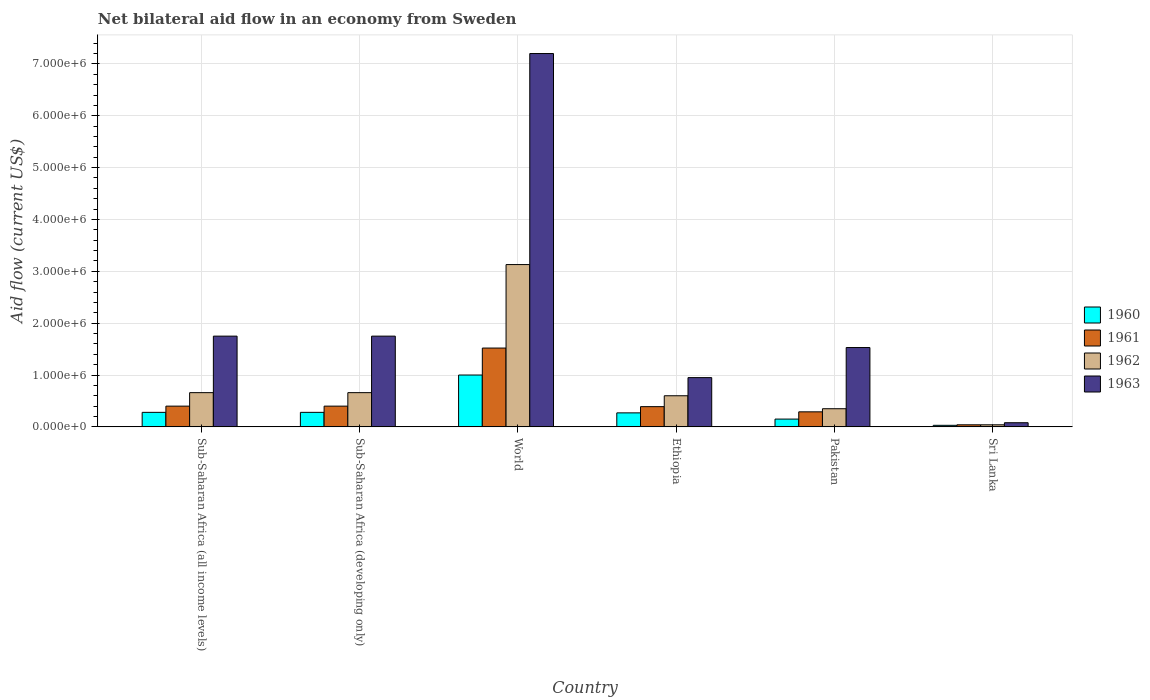How many different coloured bars are there?
Provide a short and direct response. 4. How many groups of bars are there?
Provide a short and direct response. 6. Are the number of bars on each tick of the X-axis equal?
Offer a terse response. Yes. How many bars are there on the 4th tick from the left?
Offer a terse response. 4. What is the label of the 6th group of bars from the left?
Provide a short and direct response. Sri Lanka. In how many cases, is the number of bars for a given country not equal to the number of legend labels?
Offer a very short reply. 0. Across all countries, what is the maximum net bilateral aid flow in 1963?
Offer a very short reply. 7.20e+06. Across all countries, what is the minimum net bilateral aid flow in 1962?
Give a very brief answer. 4.00e+04. In which country was the net bilateral aid flow in 1963 minimum?
Offer a very short reply. Sri Lanka. What is the total net bilateral aid flow in 1963 in the graph?
Make the answer very short. 1.33e+07. What is the average net bilateral aid flow in 1960 per country?
Provide a short and direct response. 3.35e+05. What is the difference between the net bilateral aid flow of/in 1960 and net bilateral aid flow of/in 1961 in World?
Make the answer very short. -5.20e+05. In how many countries, is the net bilateral aid flow in 1960 greater than 4600000 US$?
Offer a terse response. 0. What is the difference between the highest and the second highest net bilateral aid flow in 1960?
Keep it short and to the point. 7.20e+05. What is the difference between the highest and the lowest net bilateral aid flow in 1963?
Offer a very short reply. 7.12e+06. In how many countries, is the net bilateral aid flow in 1962 greater than the average net bilateral aid flow in 1962 taken over all countries?
Give a very brief answer. 1. Is the sum of the net bilateral aid flow in 1962 in Sub-Saharan Africa (developing only) and World greater than the maximum net bilateral aid flow in 1960 across all countries?
Your answer should be compact. Yes. How many countries are there in the graph?
Provide a short and direct response. 6. How are the legend labels stacked?
Provide a short and direct response. Vertical. What is the title of the graph?
Give a very brief answer. Net bilateral aid flow in an economy from Sweden. Does "1990" appear as one of the legend labels in the graph?
Your answer should be very brief. No. What is the label or title of the X-axis?
Offer a terse response. Country. What is the label or title of the Y-axis?
Offer a very short reply. Aid flow (current US$). What is the Aid flow (current US$) of 1962 in Sub-Saharan Africa (all income levels)?
Give a very brief answer. 6.60e+05. What is the Aid flow (current US$) in 1963 in Sub-Saharan Africa (all income levels)?
Keep it short and to the point. 1.75e+06. What is the Aid flow (current US$) in 1962 in Sub-Saharan Africa (developing only)?
Your answer should be compact. 6.60e+05. What is the Aid flow (current US$) in 1963 in Sub-Saharan Africa (developing only)?
Offer a terse response. 1.75e+06. What is the Aid flow (current US$) of 1960 in World?
Make the answer very short. 1.00e+06. What is the Aid flow (current US$) of 1961 in World?
Offer a very short reply. 1.52e+06. What is the Aid flow (current US$) of 1962 in World?
Your answer should be compact. 3.13e+06. What is the Aid flow (current US$) of 1963 in World?
Provide a short and direct response. 7.20e+06. What is the Aid flow (current US$) in 1961 in Ethiopia?
Offer a terse response. 3.90e+05. What is the Aid flow (current US$) in 1963 in Ethiopia?
Give a very brief answer. 9.50e+05. What is the Aid flow (current US$) in 1960 in Pakistan?
Ensure brevity in your answer.  1.50e+05. What is the Aid flow (current US$) of 1963 in Pakistan?
Your answer should be compact. 1.53e+06. What is the Aid flow (current US$) of 1963 in Sri Lanka?
Your answer should be compact. 8.00e+04. Across all countries, what is the maximum Aid flow (current US$) of 1961?
Make the answer very short. 1.52e+06. Across all countries, what is the maximum Aid flow (current US$) of 1962?
Make the answer very short. 3.13e+06. Across all countries, what is the maximum Aid flow (current US$) in 1963?
Offer a terse response. 7.20e+06. Across all countries, what is the minimum Aid flow (current US$) of 1961?
Keep it short and to the point. 4.00e+04. What is the total Aid flow (current US$) of 1960 in the graph?
Provide a succinct answer. 2.01e+06. What is the total Aid flow (current US$) of 1961 in the graph?
Ensure brevity in your answer.  3.04e+06. What is the total Aid flow (current US$) of 1962 in the graph?
Your response must be concise. 5.44e+06. What is the total Aid flow (current US$) of 1963 in the graph?
Your answer should be very brief. 1.33e+07. What is the difference between the Aid flow (current US$) in 1961 in Sub-Saharan Africa (all income levels) and that in Sub-Saharan Africa (developing only)?
Keep it short and to the point. 0. What is the difference between the Aid flow (current US$) of 1962 in Sub-Saharan Africa (all income levels) and that in Sub-Saharan Africa (developing only)?
Offer a terse response. 0. What is the difference between the Aid flow (current US$) in 1960 in Sub-Saharan Africa (all income levels) and that in World?
Make the answer very short. -7.20e+05. What is the difference between the Aid flow (current US$) in 1961 in Sub-Saharan Africa (all income levels) and that in World?
Make the answer very short. -1.12e+06. What is the difference between the Aid flow (current US$) in 1962 in Sub-Saharan Africa (all income levels) and that in World?
Your response must be concise. -2.47e+06. What is the difference between the Aid flow (current US$) of 1963 in Sub-Saharan Africa (all income levels) and that in World?
Your response must be concise. -5.45e+06. What is the difference between the Aid flow (current US$) in 1960 in Sub-Saharan Africa (all income levels) and that in Ethiopia?
Your answer should be compact. 10000. What is the difference between the Aid flow (current US$) of 1963 in Sub-Saharan Africa (all income levels) and that in Pakistan?
Your answer should be very brief. 2.20e+05. What is the difference between the Aid flow (current US$) of 1961 in Sub-Saharan Africa (all income levels) and that in Sri Lanka?
Your response must be concise. 3.60e+05. What is the difference between the Aid flow (current US$) of 1962 in Sub-Saharan Africa (all income levels) and that in Sri Lanka?
Ensure brevity in your answer.  6.20e+05. What is the difference between the Aid flow (current US$) of 1963 in Sub-Saharan Africa (all income levels) and that in Sri Lanka?
Provide a short and direct response. 1.67e+06. What is the difference between the Aid flow (current US$) in 1960 in Sub-Saharan Africa (developing only) and that in World?
Offer a terse response. -7.20e+05. What is the difference between the Aid flow (current US$) in 1961 in Sub-Saharan Africa (developing only) and that in World?
Ensure brevity in your answer.  -1.12e+06. What is the difference between the Aid flow (current US$) of 1962 in Sub-Saharan Africa (developing only) and that in World?
Offer a terse response. -2.47e+06. What is the difference between the Aid flow (current US$) of 1963 in Sub-Saharan Africa (developing only) and that in World?
Your answer should be very brief. -5.45e+06. What is the difference between the Aid flow (current US$) of 1960 in Sub-Saharan Africa (developing only) and that in Ethiopia?
Make the answer very short. 10000. What is the difference between the Aid flow (current US$) of 1962 in Sub-Saharan Africa (developing only) and that in Ethiopia?
Ensure brevity in your answer.  6.00e+04. What is the difference between the Aid flow (current US$) in 1963 in Sub-Saharan Africa (developing only) and that in Ethiopia?
Provide a succinct answer. 8.00e+05. What is the difference between the Aid flow (current US$) of 1962 in Sub-Saharan Africa (developing only) and that in Pakistan?
Your response must be concise. 3.10e+05. What is the difference between the Aid flow (current US$) in 1963 in Sub-Saharan Africa (developing only) and that in Pakistan?
Provide a short and direct response. 2.20e+05. What is the difference between the Aid flow (current US$) of 1960 in Sub-Saharan Africa (developing only) and that in Sri Lanka?
Make the answer very short. 2.50e+05. What is the difference between the Aid flow (current US$) of 1962 in Sub-Saharan Africa (developing only) and that in Sri Lanka?
Your answer should be very brief. 6.20e+05. What is the difference between the Aid flow (current US$) of 1963 in Sub-Saharan Africa (developing only) and that in Sri Lanka?
Provide a short and direct response. 1.67e+06. What is the difference between the Aid flow (current US$) of 1960 in World and that in Ethiopia?
Ensure brevity in your answer.  7.30e+05. What is the difference between the Aid flow (current US$) in 1961 in World and that in Ethiopia?
Give a very brief answer. 1.13e+06. What is the difference between the Aid flow (current US$) of 1962 in World and that in Ethiopia?
Make the answer very short. 2.53e+06. What is the difference between the Aid flow (current US$) of 1963 in World and that in Ethiopia?
Offer a terse response. 6.25e+06. What is the difference between the Aid flow (current US$) of 1960 in World and that in Pakistan?
Your answer should be very brief. 8.50e+05. What is the difference between the Aid flow (current US$) in 1961 in World and that in Pakistan?
Your answer should be compact. 1.23e+06. What is the difference between the Aid flow (current US$) in 1962 in World and that in Pakistan?
Your answer should be compact. 2.78e+06. What is the difference between the Aid flow (current US$) in 1963 in World and that in Pakistan?
Offer a very short reply. 5.67e+06. What is the difference between the Aid flow (current US$) in 1960 in World and that in Sri Lanka?
Ensure brevity in your answer.  9.70e+05. What is the difference between the Aid flow (current US$) of 1961 in World and that in Sri Lanka?
Ensure brevity in your answer.  1.48e+06. What is the difference between the Aid flow (current US$) of 1962 in World and that in Sri Lanka?
Your answer should be compact. 3.09e+06. What is the difference between the Aid flow (current US$) of 1963 in World and that in Sri Lanka?
Provide a succinct answer. 7.12e+06. What is the difference between the Aid flow (current US$) of 1962 in Ethiopia and that in Pakistan?
Make the answer very short. 2.50e+05. What is the difference between the Aid flow (current US$) in 1963 in Ethiopia and that in Pakistan?
Ensure brevity in your answer.  -5.80e+05. What is the difference between the Aid flow (current US$) in 1960 in Ethiopia and that in Sri Lanka?
Offer a very short reply. 2.40e+05. What is the difference between the Aid flow (current US$) in 1962 in Ethiopia and that in Sri Lanka?
Give a very brief answer. 5.60e+05. What is the difference between the Aid flow (current US$) of 1963 in Ethiopia and that in Sri Lanka?
Your answer should be compact. 8.70e+05. What is the difference between the Aid flow (current US$) in 1960 in Pakistan and that in Sri Lanka?
Provide a short and direct response. 1.20e+05. What is the difference between the Aid flow (current US$) in 1961 in Pakistan and that in Sri Lanka?
Give a very brief answer. 2.50e+05. What is the difference between the Aid flow (current US$) in 1962 in Pakistan and that in Sri Lanka?
Provide a short and direct response. 3.10e+05. What is the difference between the Aid flow (current US$) of 1963 in Pakistan and that in Sri Lanka?
Ensure brevity in your answer.  1.45e+06. What is the difference between the Aid flow (current US$) of 1960 in Sub-Saharan Africa (all income levels) and the Aid flow (current US$) of 1961 in Sub-Saharan Africa (developing only)?
Keep it short and to the point. -1.20e+05. What is the difference between the Aid flow (current US$) of 1960 in Sub-Saharan Africa (all income levels) and the Aid flow (current US$) of 1962 in Sub-Saharan Africa (developing only)?
Provide a succinct answer. -3.80e+05. What is the difference between the Aid flow (current US$) in 1960 in Sub-Saharan Africa (all income levels) and the Aid flow (current US$) in 1963 in Sub-Saharan Africa (developing only)?
Provide a succinct answer. -1.47e+06. What is the difference between the Aid flow (current US$) of 1961 in Sub-Saharan Africa (all income levels) and the Aid flow (current US$) of 1963 in Sub-Saharan Africa (developing only)?
Your answer should be compact. -1.35e+06. What is the difference between the Aid flow (current US$) in 1962 in Sub-Saharan Africa (all income levels) and the Aid flow (current US$) in 1963 in Sub-Saharan Africa (developing only)?
Make the answer very short. -1.09e+06. What is the difference between the Aid flow (current US$) in 1960 in Sub-Saharan Africa (all income levels) and the Aid flow (current US$) in 1961 in World?
Your answer should be very brief. -1.24e+06. What is the difference between the Aid flow (current US$) of 1960 in Sub-Saharan Africa (all income levels) and the Aid flow (current US$) of 1962 in World?
Offer a terse response. -2.85e+06. What is the difference between the Aid flow (current US$) of 1960 in Sub-Saharan Africa (all income levels) and the Aid flow (current US$) of 1963 in World?
Provide a succinct answer. -6.92e+06. What is the difference between the Aid flow (current US$) in 1961 in Sub-Saharan Africa (all income levels) and the Aid flow (current US$) in 1962 in World?
Keep it short and to the point. -2.73e+06. What is the difference between the Aid flow (current US$) in 1961 in Sub-Saharan Africa (all income levels) and the Aid flow (current US$) in 1963 in World?
Provide a succinct answer. -6.80e+06. What is the difference between the Aid flow (current US$) in 1962 in Sub-Saharan Africa (all income levels) and the Aid flow (current US$) in 1963 in World?
Offer a terse response. -6.54e+06. What is the difference between the Aid flow (current US$) of 1960 in Sub-Saharan Africa (all income levels) and the Aid flow (current US$) of 1961 in Ethiopia?
Ensure brevity in your answer.  -1.10e+05. What is the difference between the Aid flow (current US$) in 1960 in Sub-Saharan Africa (all income levels) and the Aid flow (current US$) in 1962 in Ethiopia?
Give a very brief answer. -3.20e+05. What is the difference between the Aid flow (current US$) in 1960 in Sub-Saharan Africa (all income levels) and the Aid flow (current US$) in 1963 in Ethiopia?
Your answer should be very brief. -6.70e+05. What is the difference between the Aid flow (current US$) in 1961 in Sub-Saharan Africa (all income levels) and the Aid flow (current US$) in 1962 in Ethiopia?
Give a very brief answer. -2.00e+05. What is the difference between the Aid flow (current US$) in 1961 in Sub-Saharan Africa (all income levels) and the Aid flow (current US$) in 1963 in Ethiopia?
Make the answer very short. -5.50e+05. What is the difference between the Aid flow (current US$) of 1962 in Sub-Saharan Africa (all income levels) and the Aid flow (current US$) of 1963 in Ethiopia?
Provide a succinct answer. -2.90e+05. What is the difference between the Aid flow (current US$) of 1960 in Sub-Saharan Africa (all income levels) and the Aid flow (current US$) of 1961 in Pakistan?
Your answer should be compact. -10000. What is the difference between the Aid flow (current US$) in 1960 in Sub-Saharan Africa (all income levels) and the Aid flow (current US$) in 1963 in Pakistan?
Your response must be concise. -1.25e+06. What is the difference between the Aid flow (current US$) in 1961 in Sub-Saharan Africa (all income levels) and the Aid flow (current US$) in 1962 in Pakistan?
Make the answer very short. 5.00e+04. What is the difference between the Aid flow (current US$) in 1961 in Sub-Saharan Africa (all income levels) and the Aid flow (current US$) in 1963 in Pakistan?
Provide a short and direct response. -1.13e+06. What is the difference between the Aid flow (current US$) in 1962 in Sub-Saharan Africa (all income levels) and the Aid flow (current US$) in 1963 in Pakistan?
Offer a very short reply. -8.70e+05. What is the difference between the Aid flow (current US$) of 1960 in Sub-Saharan Africa (all income levels) and the Aid flow (current US$) of 1961 in Sri Lanka?
Ensure brevity in your answer.  2.40e+05. What is the difference between the Aid flow (current US$) in 1960 in Sub-Saharan Africa (all income levels) and the Aid flow (current US$) in 1962 in Sri Lanka?
Provide a succinct answer. 2.40e+05. What is the difference between the Aid flow (current US$) in 1960 in Sub-Saharan Africa (all income levels) and the Aid flow (current US$) in 1963 in Sri Lanka?
Your answer should be compact. 2.00e+05. What is the difference between the Aid flow (current US$) in 1961 in Sub-Saharan Africa (all income levels) and the Aid flow (current US$) in 1962 in Sri Lanka?
Ensure brevity in your answer.  3.60e+05. What is the difference between the Aid flow (current US$) of 1962 in Sub-Saharan Africa (all income levels) and the Aid flow (current US$) of 1963 in Sri Lanka?
Keep it short and to the point. 5.80e+05. What is the difference between the Aid flow (current US$) in 1960 in Sub-Saharan Africa (developing only) and the Aid flow (current US$) in 1961 in World?
Keep it short and to the point. -1.24e+06. What is the difference between the Aid flow (current US$) in 1960 in Sub-Saharan Africa (developing only) and the Aid flow (current US$) in 1962 in World?
Make the answer very short. -2.85e+06. What is the difference between the Aid flow (current US$) in 1960 in Sub-Saharan Africa (developing only) and the Aid flow (current US$) in 1963 in World?
Your answer should be compact. -6.92e+06. What is the difference between the Aid flow (current US$) of 1961 in Sub-Saharan Africa (developing only) and the Aid flow (current US$) of 1962 in World?
Provide a succinct answer. -2.73e+06. What is the difference between the Aid flow (current US$) in 1961 in Sub-Saharan Africa (developing only) and the Aid flow (current US$) in 1963 in World?
Provide a short and direct response. -6.80e+06. What is the difference between the Aid flow (current US$) of 1962 in Sub-Saharan Africa (developing only) and the Aid flow (current US$) of 1963 in World?
Offer a terse response. -6.54e+06. What is the difference between the Aid flow (current US$) in 1960 in Sub-Saharan Africa (developing only) and the Aid flow (current US$) in 1961 in Ethiopia?
Provide a succinct answer. -1.10e+05. What is the difference between the Aid flow (current US$) of 1960 in Sub-Saharan Africa (developing only) and the Aid flow (current US$) of 1962 in Ethiopia?
Provide a succinct answer. -3.20e+05. What is the difference between the Aid flow (current US$) in 1960 in Sub-Saharan Africa (developing only) and the Aid flow (current US$) in 1963 in Ethiopia?
Provide a short and direct response. -6.70e+05. What is the difference between the Aid flow (current US$) of 1961 in Sub-Saharan Africa (developing only) and the Aid flow (current US$) of 1963 in Ethiopia?
Provide a short and direct response. -5.50e+05. What is the difference between the Aid flow (current US$) of 1960 in Sub-Saharan Africa (developing only) and the Aid flow (current US$) of 1961 in Pakistan?
Make the answer very short. -10000. What is the difference between the Aid flow (current US$) of 1960 in Sub-Saharan Africa (developing only) and the Aid flow (current US$) of 1962 in Pakistan?
Offer a very short reply. -7.00e+04. What is the difference between the Aid flow (current US$) in 1960 in Sub-Saharan Africa (developing only) and the Aid flow (current US$) in 1963 in Pakistan?
Offer a terse response. -1.25e+06. What is the difference between the Aid flow (current US$) in 1961 in Sub-Saharan Africa (developing only) and the Aid flow (current US$) in 1963 in Pakistan?
Ensure brevity in your answer.  -1.13e+06. What is the difference between the Aid flow (current US$) in 1962 in Sub-Saharan Africa (developing only) and the Aid flow (current US$) in 1963 in Pakistan?
Keep it short and to the point. -8.70e+05. What is the difference between the Aid flow (current US$) in 1960 in Sub-Saharan Africa (developing only) and the Aid flow (current US$) in 1961 in Sri Lanka?
Make the answer very short. 2.40e+05. What is the difference between the Aid flow (current US$) of 1960 in Sub-Saharan Africa (developing only) and the Aid flow (current US$) of 1963 in Sri Lanka?
Your answer should be compact. 2.00e+05. What is the difference between the Aid flow (current US$) in 1961 in Sub-Saharan Africa (developing only) and the Aid flow (current US$) in 1963 in Sri Lanka?
Offer a terse response. 3.20e+05. What is the difference between the Aid flow (current US$) in 1962 in Sub-Saharan Africa (developing only) and the Aid flow (current US$) in 1963 in Sri Lanka?
Provide a succinct answer. 5.80e+05. What is the difference between the Aid flow (current US$) in 1960 in World and the Aid flow (current US$) in 1962 in Ethiopia?
Offer a terse response. 4.00e+05. What is the difference between the Aid flow (current US$) of 1961 in World and the Aid flow (current US$) of 1962 in Ethiopia?
Give a very brief answer. 9.20e+05. What is the difference between the Aid flow (current US$) of 1961 in World and the Aid flow (current US$) of 1963 in Ethiopia?
Provide a succinct answer. 5.70e+05. What is the difference between the Aid flow (current US$) in 1962 in World and the Aid flow (current US$) in 1963 in Ethiopia?
Your answer should be very brief. 2.18e+06. What is the difference between the Aid flow (current US$) in 1960 in World and the Aid flow (current US$) in 1961 in Pakistan?
Make the answer very short. 7.10e+05. What is the difference between the Aid flow (current US$) of 1960 in World and the Aid flow (current US$) of 1962 in Pakistan?
Your response must be concise. 6.50e+05. What is the difference between the Aid flow (current US$) of 1960 in World and the Aid flow (current US$) of 1963 in Pakistan?
Offer a very short reply. -5.30e+05. What is the difference between the Aid flow (current US$) of 1961 in World and the Aid flow (current US$) of 1962 in Pakistan?
Give a very brief answer. 1.17e+06. What is the difference between the Aid flow (current US$) in 1962 in World and the Aid flow (current US$) in 1963 in Pakistan?
Ensure brevity in your answer.  1.60e+06. What is the difference between the Aid flow (current US$) in 1960 in World and the Aid flow (current US$) in 1961 in Sri Lanka?
Your answer should be very brief. 9.60e+05. What is the difference between the Aid flow (current US$) in 1960 in World and the Aid flow (current US$) in 1962 in Sri Lanka?
Provide a succinct answer. 9.60e+05. What is the difference between the Aid flow (current US$) of 1960 in World and the Aid flow (current US$) of 1963 in Sri Lanka?
Offer a very short reply. 9.20e+05. What is the difference between the Aid flow (current US$) in 1961 in World and the Aid flow (current US$) in 1962 in Sri Lanka?
Offer a very short reply. 1.48e+06. What is the difference between the Aid flow (current US$) in 1961 in World and the Aid flow (current US$) in 1963 in Sri Lanka?
Make the answer very short. 1.44e+06. What is the difference between the Aid flow (current US$) in 1962 in World and the Aid flow (current US$) in 1963 in Sri Lanka?
Keep it short and to the point. 3.05e+06. What is the difference between the Aid flow (current US$) in 1960 in Ethiopia and the Aid flow (current US$) in 1963 in Pakistan?
Ensure brevity in your answer.  -1.26e+06. What is the difference between the Aid flow (current US$) of 1961 in Ethiopia and the Aid flow (current US$) of 1962 in Pakistan?
Your answer should be very brief. 4.00e+04. What is the difference between the Aid flow (current US$) in 1961 in Ethiopia and the Aid flow (current US$) in 1963 in Pakistan?
Keep it short and to the point. -1.14e+06. What is the difference between the Aid flow (current US$) in 1962 in Ethiopia and the Aid flow (current US$) in 1963 in Pakistan?
Offer a very short reply. -9.30e+05. What is the difference between the Aid flow (current US$) in 1961 in Ethiopia and the Aid flow (current US$) in 1962 in Sri Lanka?
Provide a short and direct response. 3.50e+05. What is the difference between the Aid flow (current US$) of 1961 in Ethiopia and the Aid flow (current US$) of 1963 in Sri Lanka?
Your answer should be compact. 3.10e+05. What is the difference between the Aid flow (current US$) in 1962 in Ethiopia and the Aid flow (current US$) in 1963 in Sri Lanka?
Your answer should be very brief. 5.20e+05. What is the difference between the Aid flow (current US$) in 1960 in Pakistan and the Aid flow (current US$) in 1961 in Sri Lanka?
Give a very brief answer. 1.10e+05. What is the difference between the Aid flow (current US$) of 1960 in Pakistan and the Aid flow (current US$) of 1963 in Sri Lanka?
Give a very brief answer. 7.00e+04. What is the difference between the Aid flow (current US$) in 1961 in Pakistan and the Aid flow (current US$) in 1962 in Sri Lanka?
Give a very brief answer. 2.50e+05. What is the difference between the Aid flow (current US$) of 1961 in Pakistan and the Aid flow (current US$) of 1963 in Sri Lanka?
Provide a short and direct response. 2.10e+05. What is the difference between the Aid flow (current US$) in 1962 in Pakistan and the Aid flow (current US$) in 1963 in Sri Lanka?
Ensure brevity in your answer.  2.70e+05. What is the average Aid flow (current US$) of 1960 per country?
Provide a succinct answer. 3.35e+05. What is the average Aid flow (current US$) of 1961 per country?
Provide a short and direct response. 5.07e+05. What is the average Aid flow (current US$) of 1962 per country?
Provide a short and direct response. 9.07e+05. What is the average Aid flow (current US$) in 1963 per country?
Provide a succinct answer. 2.21e+06. What is the difference between the Aid flow (current US$) of 1960 and Aid flow (current US$) of 1961 in Sub-Saharan Africa (all income levels)?
Provide a succinct answer. -1.20e+05. What is the difference between the Aid flow (current US$) of 1960 and Aid flow (current US$) of 1962 in Sub-Saharan Africa (all income levels)?
Keep it short and to the point. -3.80e+05. What is the difference between the Aid flow (current US$) of 1960 and Aid flow (current US$) of 1963 in Sub-Saharan Africa (all income levels)?
Your answer should be compact. -1.47e+06. What is the difference between the Aid flow (current US$) of 1961 and Aid flow (current US$) of 1962 in Sub-Saharan Africa (all income levels)?
Your answer should be very brief. -2.60e+05. What is the difference between the Aid flow (current US$) in 1961 and Aid flow (current US$) in 1963 in Sub-Saharan Africa (all income levels)?
Offer a terse response. -1.35e+06. What is the difference between the Aid flow (current US$) of 1962 and Aid flow (current US$) of 1963 in Sub-Saharan Africa (all income levels)?
Your answer should be very brief. -1.09e+06. What is the difference between the Aid flow (current US$) in 1960 and Aid flow (current US$) in 1962 in Sub-Saharan Africa (developing only)?
Offer a very short reply. -3.80e+05. What is the difference between the Aid flow (current US$) of 1960 and Aid flow (current US$) of 1963 in Sub-Saharan Africa (developing only)?
Offer a terse response. -1.47e+06. What is the difference between the Aid flow (current US$) of 1961 and Aid flow (current US$) of 1962 in Sub-Saharan Africa (developing only)?
Your answer should be compact. -2.60e+05. What is the difference between the Aid flow (current US$) of 1961 and Aid flow (current US$) of 1963 in Sub-Saharan Africa (developing only)?
Offer a terse response. -1.35e+06. What is the difference between the Aid flow (current US$) in 1962 and Aid flow (current US$) in 1963 in Sub-Saharan Africa (developing only)?
Offer a very short reply. -1.09e+06. What is the difference between the Aid flow (current US$) of 1960 and Aid flow (current US$) of 1961 in World?
Make the answer very short. -5.20e+05. What is the difference between the Aid flow (current US$) in 1960 and Aid flow (current US$) in 1962 in World?
Give a very brief answer. -2.13e+06. What is the difference between the Aid flow (current US$) of 1960 and Aid flow (current US$) of 1963 in World?
Offer a very short reply. -6.20e+06. What is the difference between the Aid flow (current US$) in 1961 and Aid flow (current US$) in 1962 in World?
Your answer should be compact. -1.61e+06. What is the difference between the Aid flow (current US$) in 1961 and Aid flow (current US$) in 1963 in World?
Offer a very short reply. -5.68e+06. What is the difference between the Aid flow (current US$) in 1962 and Aid flow (current US$) in 1963 in World?
Your answer should be very brief. -4.07e+06. What is the difference between the Aid flow (current US$) of 1960 and Aid flow (current US$) of 1961 in Ethiopia?
Give a very brief answer. -1.20e+05. What is the difference between the Aid flow (current US$) of 1960 and Aid flow (current US$) of 1962 in Ethiopia?
Keep it short and to the point. -3.30e+05. What is the difference between the Aid flow (current US$) of 1960 and Aid flow (current US$) of 1963 in Ethiopia?
Provide a succinct answer. -6.80e+05. What is the difference between the Aid flow (current US$) in 1961 and Aid flow (current US$) in 1962 in Ethiopia?
Offer a very short reply. -2.10e+05. What is the difference between the Aid flow (current US$) of 1961 and Aid flow (current US$) of 1963 in Ethiopia?
Offer a terse response. -5.60e+05. What is the difference between the Aid flow (current US$) of 1962 and Aid flow (current US$) of 1963 in Ethiopia?
Offer a terse response. -3.50e+05. What is the difference between the Aid flow (current US$) in 1960 and Aid flow (current US$) in 1963 in Pakistan?
Offer a very short reply. -1.38e+06. What is the difference between the Aid flow (current US$) in 1961 and Aid flow (current US$) in 1963 in Pakistan?
Make the answer very short. -1.24e+06. What is the difference between the Aid flow (current US$) in 1962 and Aid flow (current US$) in 1963 in Pakistan?
Your answer should be compact. -1.18e+06. What is the difference between the Aid flow (current US$) of 1960 and Aid flow (current US$) of 1962 in Sri Lanka?
Your answer should be very brief. -10000. What is the difference between the Aid flow (current US$) of 1961 and Aid flow (current US$) of 1963 in Sri Lanka?
Ensure brevity in your answer.  -4.00e+04. What is the difference between the Aid flow (current US$) of 1962 and Aid flow (current US$) of 1963 in Sri Lanka?
Provide a short and direct response. -4.00e+04. What is the ratio of the Aid flow (current US$) in 1961 in Sub-Saharan Africa (all income levels) to that in Sub-Saharan Africa (developing only)?
Offer a terse response. 1. What is the ratio of the Aid flow (current US$) in 1963 in Sub-Saharan Africa (all income levels) to that in Sub-Saharan Africa (developing only)?
Your answer should be compact. 1. What is the ratio of the Aid flow (current US$) in 1960 in Sub-Saharan Africa (all income levels) to that in World?
Provide a succinct answer. 0.28. What is the ratio of the Aid flow (current US$) in 1961 in Sub-Saharan Africa (all income levels) to that in World?
Your answer should be very brief. 0.26. What is the ratio of the Aid flow (current US$) in 1962 in Sub-Saharan Africa (all income levels) to that in World?
Give a very brief answer. 0.21. What is the ratio of the Aid flow (current US$) of 1963 in Sub-Saharan Africa (all income levels) to that in World?
Offer a very short reply. 0.24. What is the ratio of the Aid flow (current US$) of 1961 in Sub-Saharan Africa (all income levels) to that in Ethiopia?
Provide a short and direct response. 1.03. What is the ratio of the Aid flow (current US$) of 1963 in Sub-Saharan Africa (all income levels) to that in Ethiopia?
Offer a very short reply. 1.84. What is the ratio of the Aid flow (current US$) in 1960 in Sub-Saharan Africa (all income levels) to that in Pakistan?
Provide a short and direct response. 1.87. What is the ratio of the Aid flow (current US$) of 1961 in Sub-Saharan Africa (all income levels) to that in Pakistan?
Provide a short and direct response. 1.38. What is the ratio of the Aid flow (current US$) in 1962 in Sub-Saharan Africa (all income levels) to that in Pakistan?
Your answer should be very brief. 1.89. What is the ratio of the Aid flow (current US$) in 1963 in Sub-Saharan Africa (all income levels) to that in Pakistan?
Make the answer very short. 1.14. What is the ratio of the Aid flow (current US$) of 1960 in Sub-Saharan Africa (all income levels) to that in Sri Lanka?
Your answer should be very brief. 9.33. What is the ratio of the Aid flow (current US$) in 1961 in Sub-Saharan Africa (all income levels) to that in Sri Lanka?
Ensure brevity in your answer.  10. What is the ratio of the Aid flow (current US$) of 1962 in Sub-Saharan Africa (all income levels) to that in Sri Lanka?
Ensure brevity in your answer.  16.5. What is the ratio of the Aid flow (current US$) in 1963 in Sub-Saharan Africa (all income levels) to that in Sri Lanka?
Your answer should be very brief. 21.88. What is the ratio of the Aid flow (current US$) of 1960 in Sub-Saharan Africa (developing only) to that in World?
Your answer should be very brief. 0.28. What is the ratio of the Aid flow (current US$) in 1961 in Sub-Saharan Africa (developing only) to that in World?
Ensure brevity in your answer.  0.26. What is the ratio of the Aid flow (current US$) of 1962 in Sub-Saharan Africa (developing only) to that in World?
Give a very brief answer. 0.21. What is the ratio of the Aid flow (current US$) of 1963 in Sub-Saharan Africa (developing only) to that in World?
Provide a short and direct response. 0.24. What is the ratio of the Aid flow (current US$) in 1960 in Sub-Saharan Africa (developing only) to that in Ethiopia?
Your answer should be compact. 1.04. What is the ratio of the Aid flow (current US$) of 1961 in Sub-Saharan Africa (developing only) to that in Ethiopia?
Ensure brevity in your answer.  1.03. What is the ratio of the Aid flow (current US$) of 1962 in Sub-Saharan Africa (developing only) to that in Ethiopia?
Give a very brief answer. 1.1. What is the ratio of the Aid flow (current US$) of 1963 in Sub-Saharan Africa (developing only) to that in Ethiopia?
Your answer should be very brief. 1.84. What is the ratio of the Aid flow (current US$) of 1960 in Sub-Saharan Africa (developing only) to that in Pakistan?
Your answer should be very brief. 1.87. What is the ratio of the Aid flow (current US$) of 1961 in Sub-Saharan Africa (developing only) to that in Pakistan?
Your answer should be compact. 1.38. What is the ratio of the Aid flow (current US$) in 1962 in Sub-Saharan Africa (developing only) to that in Pakistan?
Keep it short and to the point. 1.89. What is the ratio of the Aid flow (current US$) in 1963 in Sub-Saharan Africa (developing only) to that in Pakistan?
Your response must be concise. 1.14. What is the ratio of the Aid flow (current US$) in 1960 in Sub-Saharan Africa (developing only) to that in Sri Lanka?
Make the answer very short. 9.33. What is the ratio of the Aid flow (current US$) of 1961 in Sub-Saharan Africa (developing only) to that in Sri Lanka?
Provide a short and direct response. 10. What is the ratio of the Aid flow (current US$) of 1962 in Sub-Saharan Africa (developing only) to that in Sri Lanka?
Your response must be concise. 16.5. What is the ratio of the Aid flow (current US$) in 1963 in Sub-Saharan Africa (developing only) to that in Sri Lanka?
Keep it short and to the point. 21.88. What is the ratio of the Aid flow (current US$) in 1960 in World to that in Ethiopia?
Your answer should be very brief. 3.7. What is the ratio of the Aid flow (current US$) of 1961 in World to that in Ethiopia?
Offer a terse response. 3.9. What is the ratio of the Aid flow (current US$) of 1962 in World to that in Ethiopia?
Give a very brief answer. 5.22. What is the ratio of the Aid flow (current US$) in 1963 in World to that in Ethiopia?
Ensure brevity in your answer.  7.58. What is the ratio of the Aid flow (current US$) of 1961 in World to that in Pakistan?
Give a very brief answer. 5.24. What is the ratio of the Aid flow (current US$) of 1962 in World to that in Pakistan?
Your answer should be compact. 8.94. What is the ratio of the Aid flow (current US$) of 1963 in World to that in Pakistan?
Offer a terse response. 4.71. What is the ratio of the Aid flow (current US$) of 1960 in World to that in Sri Lanka?
Make the answer very short. 33.33. What is the ratio of the Aid flow (current US$) of 1962 in World to that in Sri Lanka?
Offer a terse response. 78.25. What is the ratio of the Aid flow (current US$) of 1961 in Ethiopia to that in Pakistan?
Offer a terse response. 1.34. What is the ratio of the Aid flow (current US$) of 1962 in Ethiopia to that in Pakistan?
Offer a terse response. 1.71. What is the ratio of the Aid flow (current US$) in 1963 in Ethiopia to that in Pakistan?
Your answer should be compact. 0.62. What is the ratio of the Aid flow (current US$) of 1961 in Ethiopia to that in Sri Lanka?
Offer a very short reply. 9.75. What is the ratio of the Aid flow (current US$) in 1963 in Ethiopia to that in Sri Lanka?
Provide a short and direct response. 11.88. What is the ratio of the Aid flow (current US$) of 1960 in Pakistan to that in Sri Lanka?
Provide a succinct answer. 5. What is the ratio of the Aid flow (current US$) in 1961 in Pakistan to that in Sri Lanka?
Make the answer very short. 7.25. What is the ratio of the Aid flow (current US$) in 1962 in Pakistan to that in Sri Lanka?
Ensure brevity in your answer.  8.75. What is the ratio of the Aid flow (current US$) of 1963 in Pakistan to that in Sri Lanka?
Provide a short and direct response. 19.12. What is the difference between the highest and the second highest Aid flow (current US$) in 1960?
Offer a terse response. 7.20e+05. What is the difference between the highest and the second highest Aid flow (current US$) in 1961?
Offer a very short reply. 1.12e+06. What is the difference between the highest and the second highest Aid flow (current US$) of 1962?
Offer a terse response. 2.47e+06. What is the difference between the highest and the second highest Aid flow (current US$) in 1963?
Keep it short and to the point. 5.45e+06. What is the difference between the highest and the lowest Aid flow (current US$) in 1960?
Your answer should be compact. 9.70e+05. What is the difference between the highest and the lowest Aid flow (current US$) in 1961?
Offer a terse response. 1.48e+06. What is the difference between the highest and the lowest Aid flow (current US$) of 1962?
Offer a very short reply. 3.09e+06. What is the difference between the highest and the lowest Aid flow (current US$) of 1963?
Provide a short and direct response. 7.12e+06. 